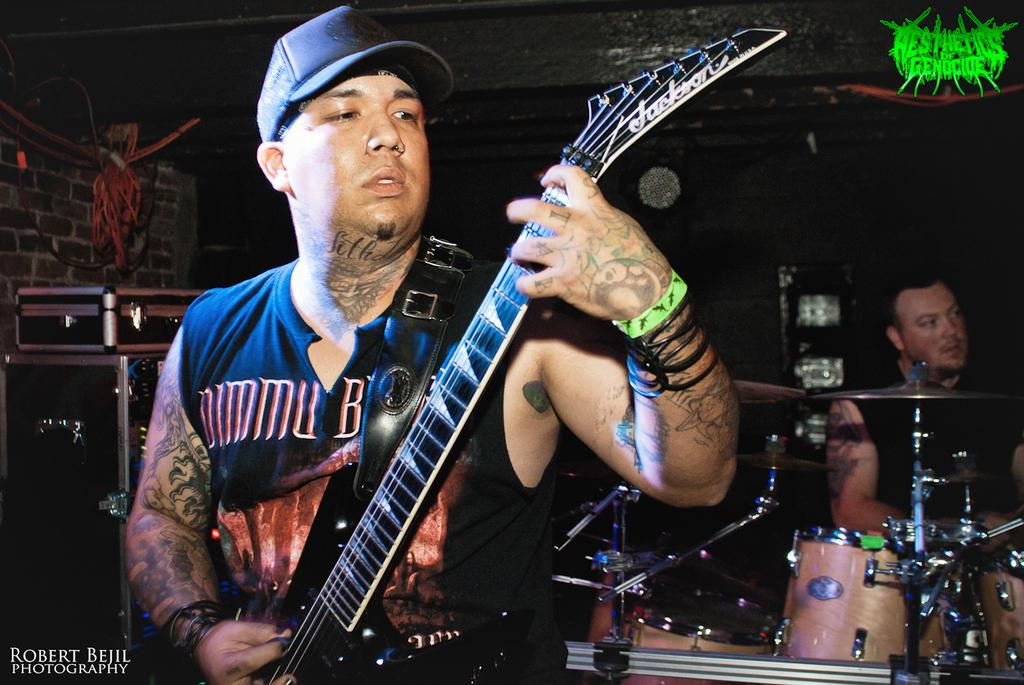What is the main subject of the image? The main subject of the image is a tattooed guy. What is the tattooed guy doing in the image? The tattooed guy is playing a guitar. Are there any other people in the image? Yes, there are men playing musical instruments in the background. What can be seen near the musicians in the background? There are black sound boxes in the background. Is there any blood visible on the tattooed guy's nose in the image? No, there is no blood visible on the tattooed guy's nose in the image. 